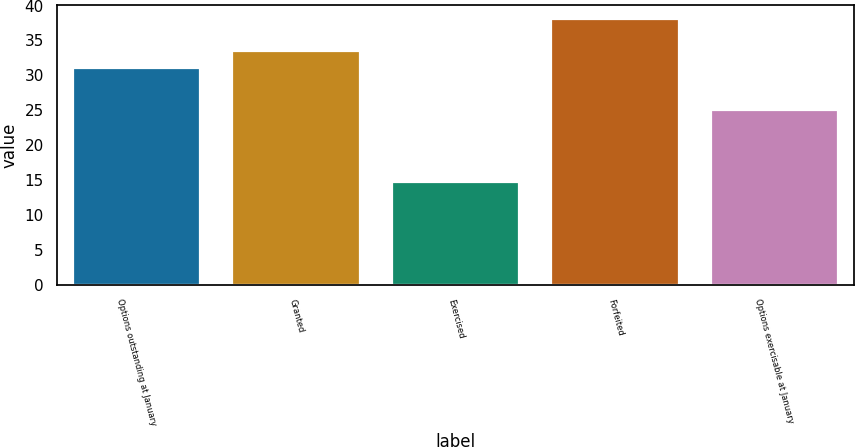Convert chart. <chart><loc_0><loc_0><loc_500><loc_500><bar_chart><fcel>Options outstanding at January<fcel>Granted<fcel>Exercised<fcel>Forfeited<fcel>Options exercisable at January<nl><fcel>31.09<fcel>33.43<fcel>14.71<fcel>38.11<fcel>25.01<nl></chart> 